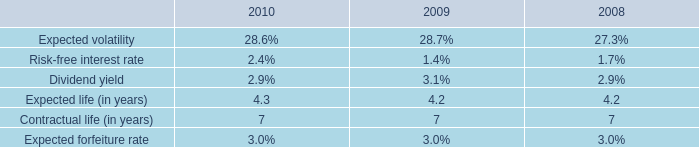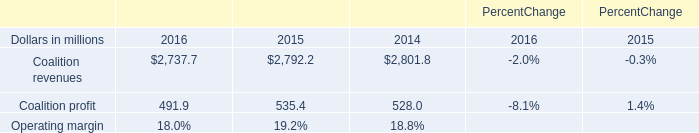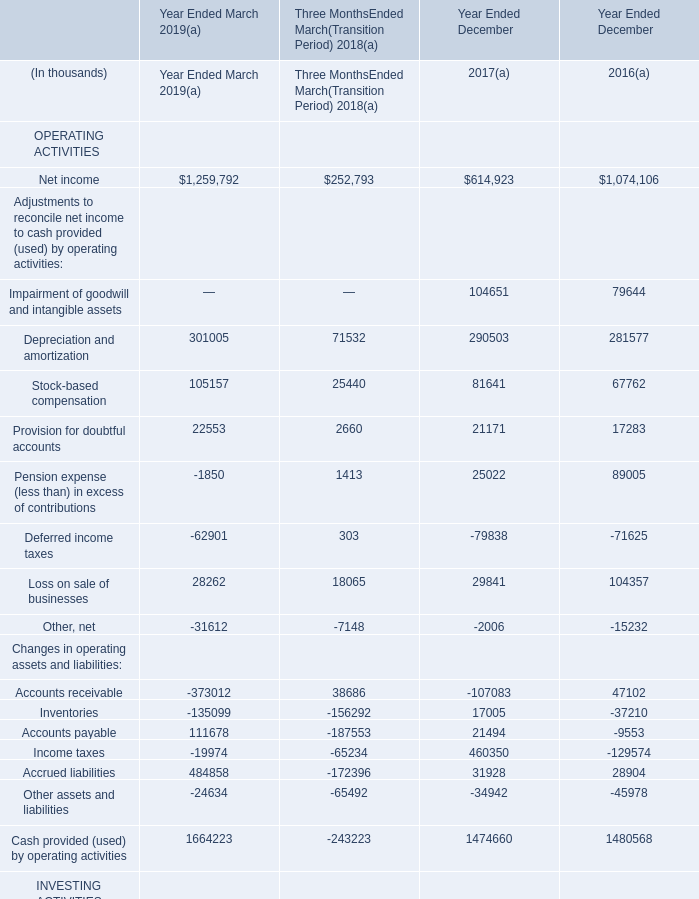What is the percentage of other current assets in relation to the total in 2019 ? (in %) 
Computations: (3645 / 556587)
Answer: 0.00655. 